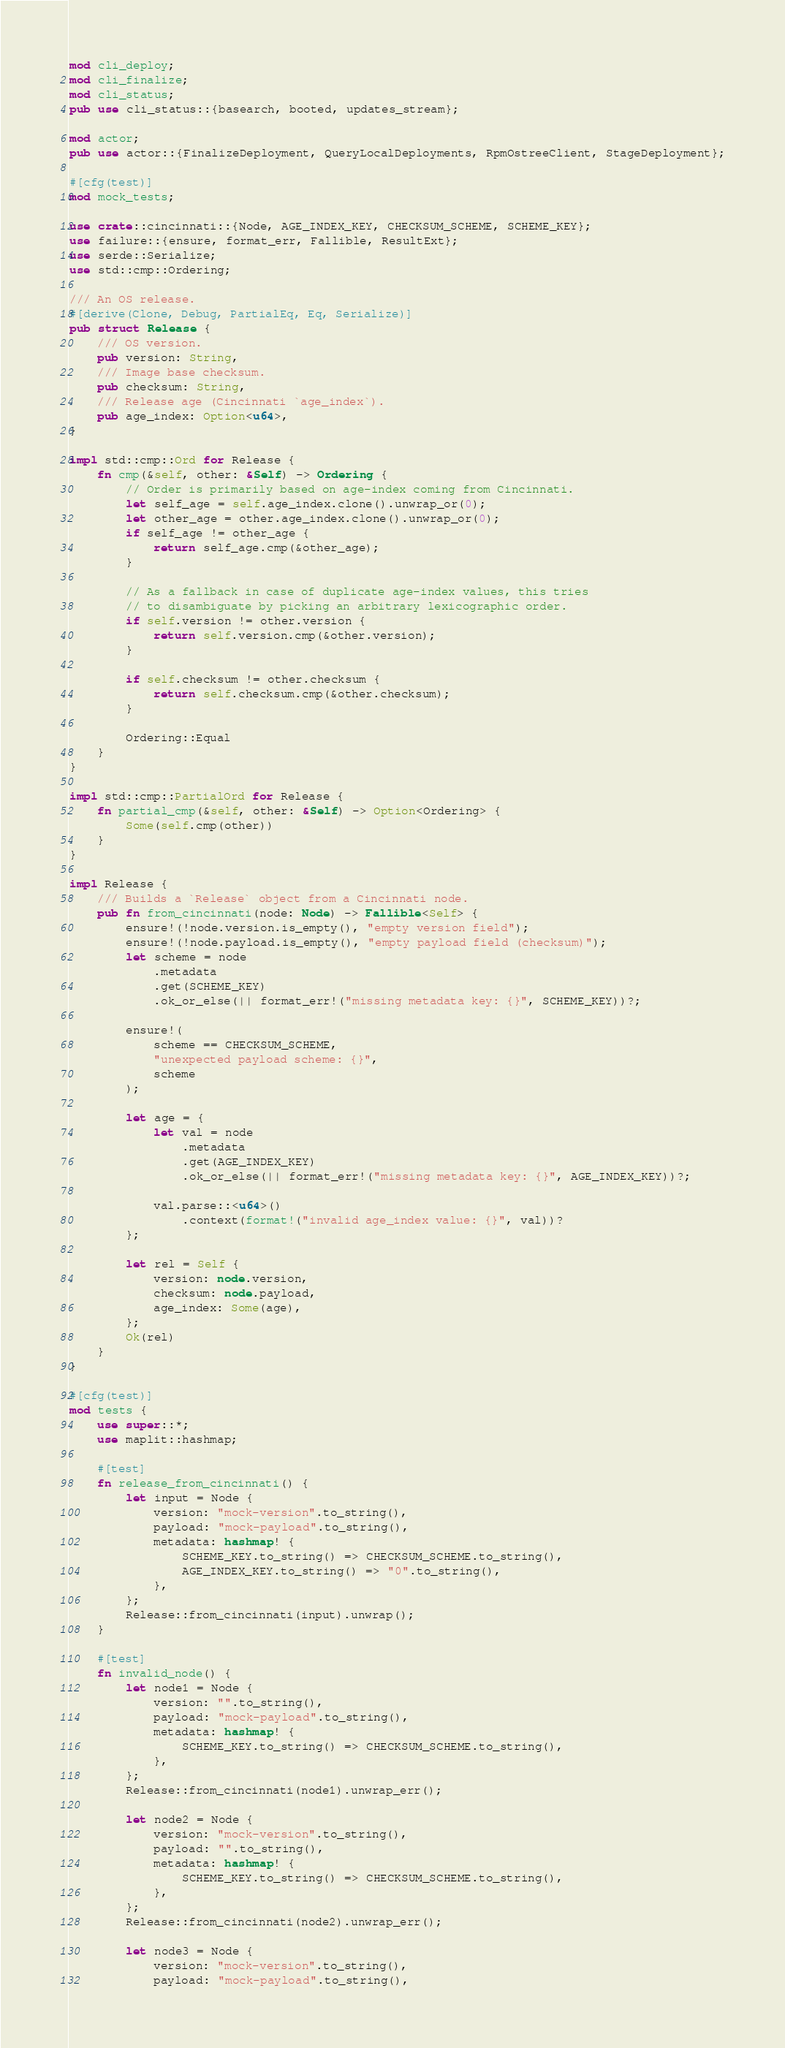<code> <loc_0><loc_0><loc_500><loc_500><_Rust_>mod cli_deploy;
mod cli_finalize;
mod cli_status;
pub use cli_status::{basearch, booted, updates_stream};

mod actor;
pub use actor::{FinalizeDeployment, QueryLocalDeployments, RpmOstreeClient, StageDeployment};

#[cfg(test)]
mod mock_tests;

use crate::cincinnati::{Node, AGE_INDEX_KEY, CHECKSUM_SCHEME, SCHEME_KEY};
use failure::{ensure, format_err, Fallible, ResultExt};
use serde::Serialize;
use std::cmp::Ordering;

/// An OS release.
#[derive(Clone, Debug, PartialEq, Eq, Serialize)]
pub struct Release {
    /// OS version.
    pub version: String,
    /// Image base checksum.
    pub checksum: String,
    /// Release age (Cincinnati `age_index`).
    pub age_index: Option<u64>,
}

impl std::cmp::Ord for Release {
    fn cmp(&self, other: &Self) -> Ordering {
        // Order is primarily based on age-index coming from Cincinnati.
        let self_age = self.age_index.clone().unwrap_or(0);
        let other_age = other.age_index.clone().unwrap_or(0);
        if self_age != other_age {
            return self_age.cmp(&other_age);
        }

        // As a fallback in case of duplicate age-index values, this tries
        // to disambiguate by picking an arbitrary lexicographic order.
        if self.version != other.version {
            return self.version.cmp(&other.version);
        }

        if self.checksum != other.checksum {
            return self.checksum.cmp(&other.checksum);
        }

        Ordering::Equal
    }
}

impl std::cmp::PartialOrd for Release {
    fn partial_cmp(&self, other: &Self) -> Option<Ordering> {
        Some(self.cmp(other))
    }
}

impl Release {
    /// Builds a `Release` object from a Cincinnati node.
    pub fn from_cincinnati(node: Node) -> Fallible<Self> {
        ensure!(!node.version.is_empty(), "empty version field");
        ensure!(!node.payload.is_empty(), "empty payload field (checksum)");
        let scheme = node
            .metadata
            .get(SCHEME_KEY)
            .ok_or_else(|| format_err!("missing metadata key: {}", SCHEME_KEY))?;

        ensure!(
            scheme == CHECKSUM_SCHEME,
            "unexpected payload scheme: {}",
            scheme
        );

        let age = {
            let val = node
                .metadata
                .get(AGE_INDEX_KEY)
                .ok_or_else(|| format_err!("missing metadata key: {}", AGE_INDEX_KEY))?;

            val.parse::<u64>()
                .context(format!("invalid age_index value: {}", val))?
        };

        let rel = Self {
            version: node.version,
            checksum: node.payload,
            age_index: Some(age),
        };
        Ok(rel)
    }
}

#[cfg(test)]
mod tests {
    use super::*;
    use maplit::hashmap;

    #[test]
    fn release_from_cincinnati() {
        let input = Node {
            version: "mock-version".to_string(),
            payload: "mock-payload".to_string(),
            metadata: hashmap! {
                SCHEME_KEY.to_string() => CHECKSUM_SCHEME.to_string(),
                AGE_INDEX_KEY.to_string() => "0".to_string(),
            },
        };
        Release::from_cincinnati(input).unwrap();
    }

    #[test]
    fn invalid_node() {
        let node1 = Node {
            version: "".to_string(),
            payload: "mock-payload".to_string(),
            metadata: hashmap! {
                SCHEME_KEY.to_string() => CHECKSUM_SCHEME.to_string(),
            },
        };
        Release::from_cincinnati(node1).unwrap_err();

        let node2 = Node {
            version: "mock-version".to_string(),
            payload: "".to_string(),
            metadata: hashmap! {
                SCHEME_KEY.to_string() => CHECKSUM_SCHEME.to_string(),
            },
        };
        Release::from_cincinnati(node2).unwrap_err();

        let node3 = Node {
            version: "mock-version".to_string(),
            payload: "mock-payload".to_string(),</code> 